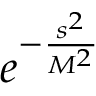<formula> <loc_0><loc_0><loc_500><loc_500>e ^ { - \frac { s ^ { 2 } } { M ^ { 2 } } }</formula> 